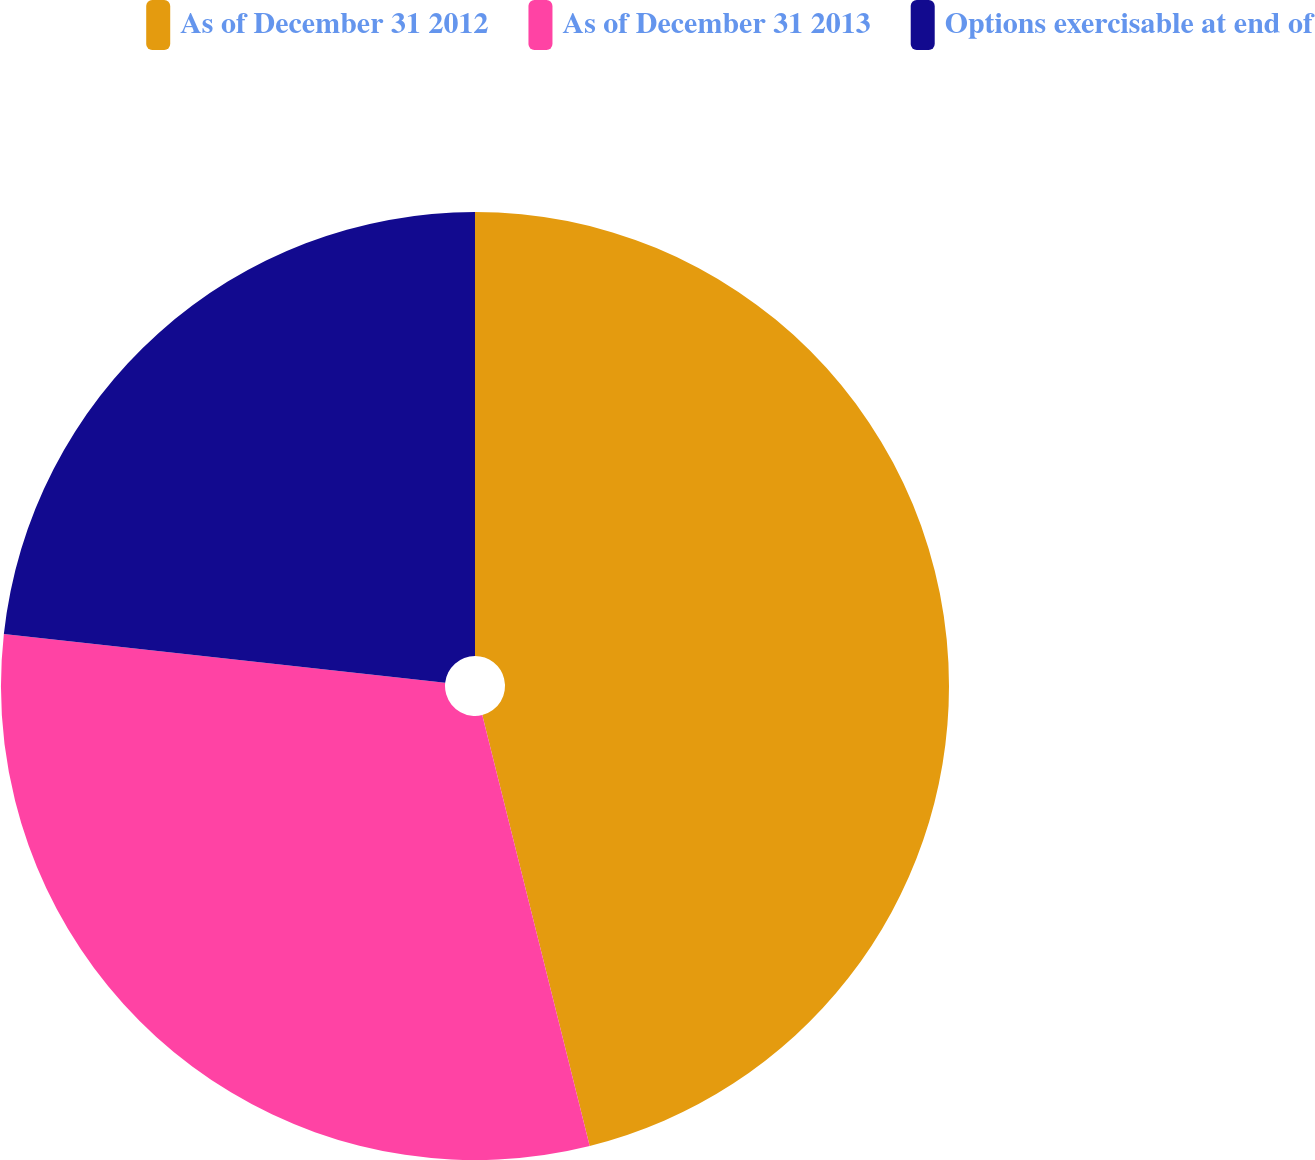Convert chart. <chart><loc_0><loc_0><loc_500><loc_500><pie_chart><fcel>As of December 31 2012<fcel>As of December 31 2013<fcel>Options exercisable at end of<nl><fcel>46.11%<fcel>30.64%<fcel>23.25%<nl></chart> 